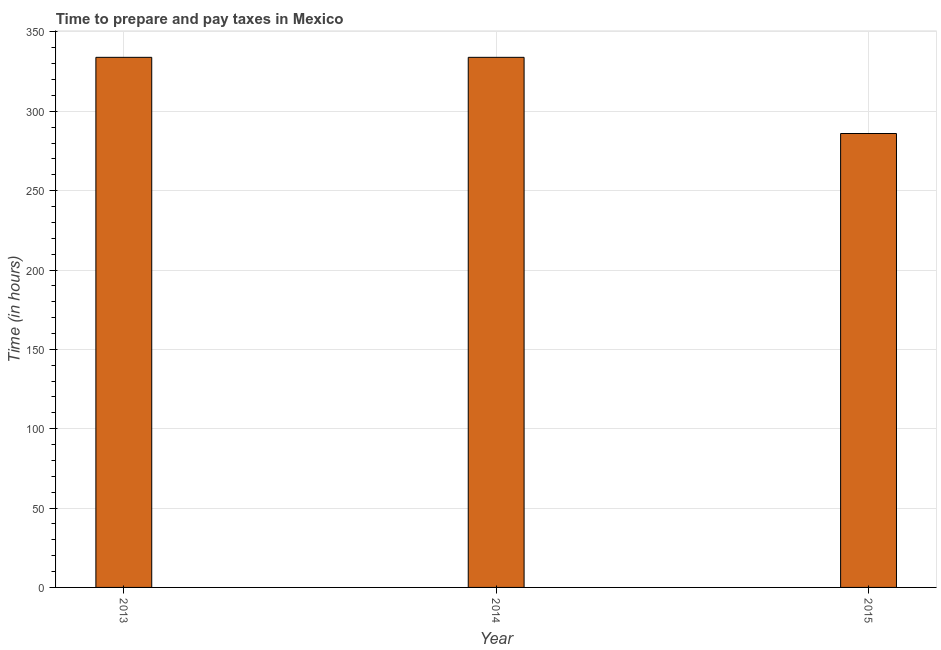Does the graph contain grids?
Keep it short and to the point. Yes. What is the title of the graph?
Keep it short and to the point. Time to prepare and pay taxes in Mexico. What is the label or title of the Y-axis?
Provide a succinct answer. Time (in hours). What is the time to prepare and pay taxes in 2013?
Keep it short and to the point. 334. Across all years, what is the maximum time to prepare and pay taxes?
Offer a terse response. 334. Across all years, what is the minimum time to prepare and pay taxes?
Offer a very short reply. 286. In which year was the time to prepare and pay taxes maximum?
Keep it short and to the point. 2013. In which year was the time to prepare and pay taxes minimum?
Ensure brevity in your answer.  2015. What is the sum of the time to prepare and pay taxes?
Offer a terse response. 954. What is the difference between the time to prepare and pay taxes in 2013 and 2014?
Your answer should be very brief. 0. What is the average time to prepare and pay taxes per year?
Your response must be concise. 318. What is the median time to prepare and pay taxes?
Make the answer very short. 334. Do a majority of the years between 2015 and 2014 (inclusive) have time to prepare and pay taxes greater than 330 hours?
Give a very brief answer. No. What is the ratio of the time to prepare and pay taxes in 2014 to that in 2015?
Offer a very short reply. 1.17. Is the time to prepare and pay taxes in 2013 less than that in 2015?
Provide a succinct answer. No. Is the difference between the time to prepare and pay taxes in 2013 and 2015 greater than the difference between any two years?
Give a very brief answer. Yes. Is the sum of the time to prepare and pay taxes in 2013 and 2014 greater than the maximum time to prepare and pay taxes across all years?
Give a very brief answer. Yes. Are all the bars in the graph horizontal?
Give a very brief answer. No. Are the values on the major ticks of Y-axis written in scientific E-notation?
Make the answer very short. No. What is the Time (in hours) in 2013?
Provide a short and direct response. 334. What is the Time (in hours) in 2014?
Give a very brief answer. 334. What is the Time (in hours) in 2015?
Provide a succinct answer. 286. What is the difference between the Time (in hours) in 2013 and 2015?
Your answer should be very brief. 48. What is the ratio of the Time (in hours) in 2013 to that in 2014?
Your answer should be very brief. 1. What is the ratio of the Time (in hours) in 2013 to that in 2015?
Ensure brevity in your answer.  1.17. What is the ratio of the Time (in hours) in 2014 to that in 2015?
Your answer should be compact. 1.17. 